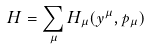Convert formula to latex. <formula><loc_0><loc_0><loc_500><loc_500>H = \sum _ { \mu } H _ { \mu } ( y ^ { \mu } , p _ { \mu } )</formula> 